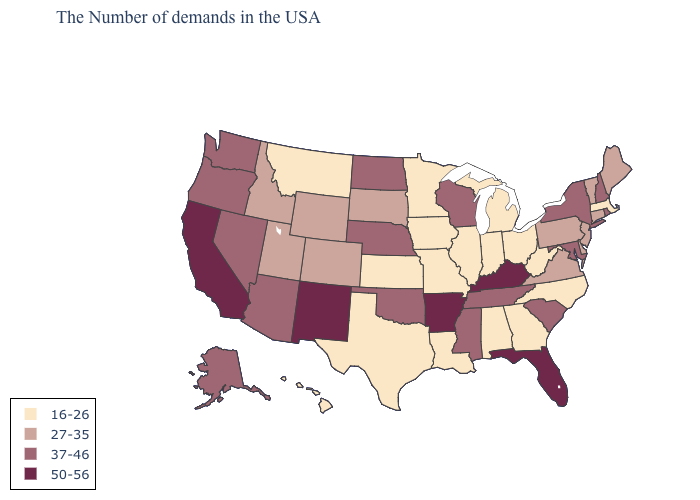Which states have the highest value in the USA?
Quick response, please. Florida, Kentucky, Arkansas, New Mexico, California. What is the value of Washington?
Quick response, please. 37-46. What is the value of Idaho?
Give a very brief answer. 27-35. Does Alaska have the lowest value in the West?
Short answer required. No. Which states hav the highest value in the West?
Short answer required. New Mexico, California. Name the states that have a value in the range 50-56?
Answer briefly. Florida, Kentucky, Arkansas, New Mexico, California. Which states have the lowest value in the West?
Be succinct. Montana, Hawaii. Name the states that have a value in the range 16-26?
Answer briefly. Massachusetts, North Carolina, West Virginia, Ohio, Georgia, Michigan, Indiana, Alabama, Illinois, Louisiana, Missouri, Minnesota, Iowa, Kansas, Texas, Montana, Hawaii. Name the states that have a value in the range 50-56?
Be succinct. Florida, Kentucky, Arkansas, New Mexico, California. Which states hav the highest value in the South?
Quick response, please. Florida, Kentucky, Arkansas. What is the value of Kansas?
Give a very brief answer. 16-26. Among the states that border New York , which have the lowest value?
Give a very brief answer. Massachusetts. Which states have the lowest value in the USA?
Write a very short answer. Massachusetts, North Carolina, West Virginia, Ohio, Georgia, Michigan, Indiana, Alabama, Illinois, Louisiana, Missouri, Minnesota, Iowa, Kansas, Texas, Montana, Hawaii. Does New Mexico have the highest value in the USA?
Write a very short answer. Yes. 